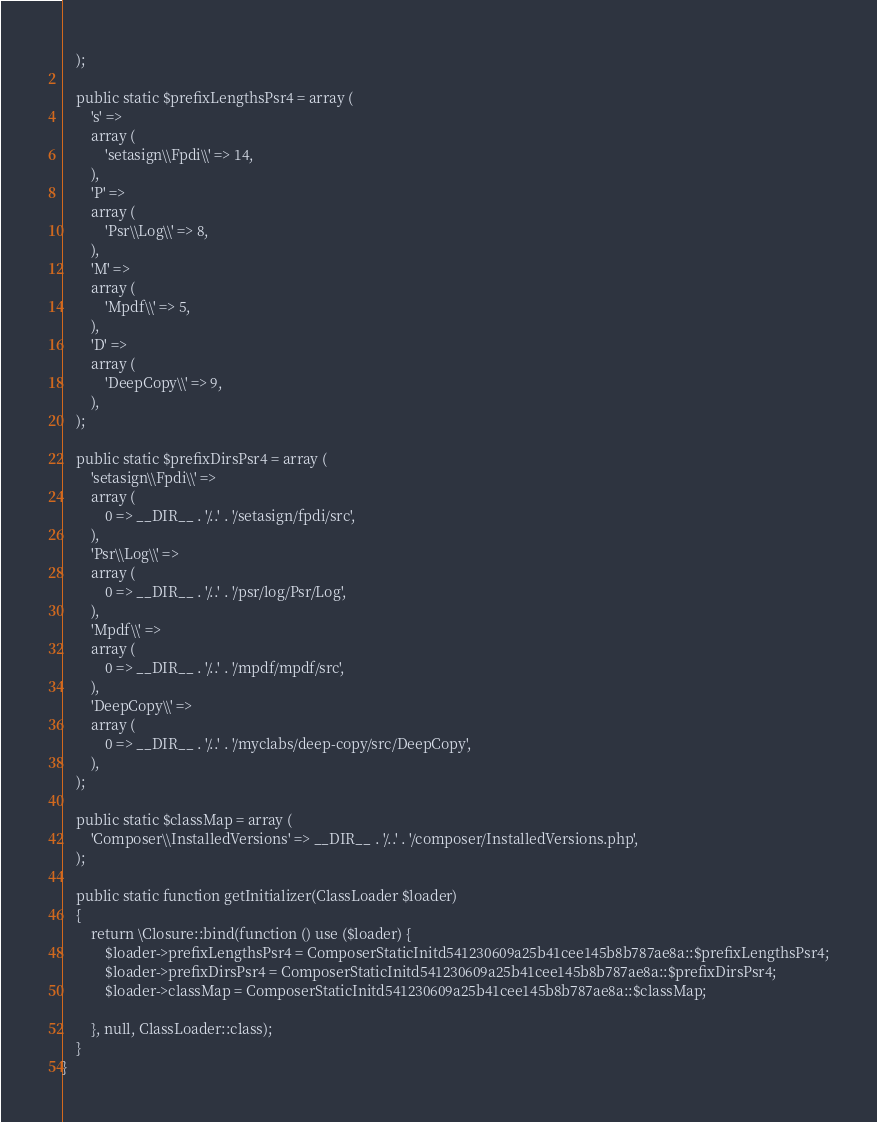<code> <loc_0><loc_0><loc_500><loc_500><_PHP_>    );

    public static $prefixLengthsPsr4 = array (
        's' => 
        array (
            'setasign\\Fpdi\\' => 14,
        ),
        'P' => 
        array (
            'Psr\\Log\\' => 8,
        ),
        'M' => 
        array (
            'Mpdf\\' => 5,
        ),
        'D' => 
        array (
            'DeepCopy\\' => 9,
        ),
    );

    public static $prefixDirsPsr4 = array (
        'setasign\\Fpdi\\' => 
        array (
            0 => __DIR__ . '/..' . '/setasign/fpdi/src',
        ),
        'Psr\\Log\\' => 
        array (
            0 => __DIR__ . '/..' . '/psr/log/Psr/Log',
        ),
        'Mpdf\\' => 
        array (
            0 => __DIR__ . '/..' . '/mpdf/mpdf/src',
        ),
        'DeepCopy\\' => 
        array (
            0 => __DIR__ . '/..' . '/myclabs/deep-copy/src/DeepCopy',
        ),
    );

    public static $classMap = array (
        'Composer\\InstalledVersions' => __DIR__ . '/..' . '/composer/InstalledVersions.php',
    );

    public static function getInitializer(ClassLoader $loader)
    {
        return \Closure::bind(function () use ($loader) {
            $loader->prefixLengthsPsr4 = ComposerStaticInitd541230609a25b41cee145b8b787ae8a::$prefixLengthsPsr4;
            $loader->prefixDirsPsr4 = ComposerStaticInitd541230609a25b41cee145b8b787ae8a::$prefixDirsPsr4;
            $loader->classMap = ComposerStaticInitd541230609a25b41cee145b8b787ae8a::$classMap;

        }, null, ClassLoader::class);
    }
}
</code> 